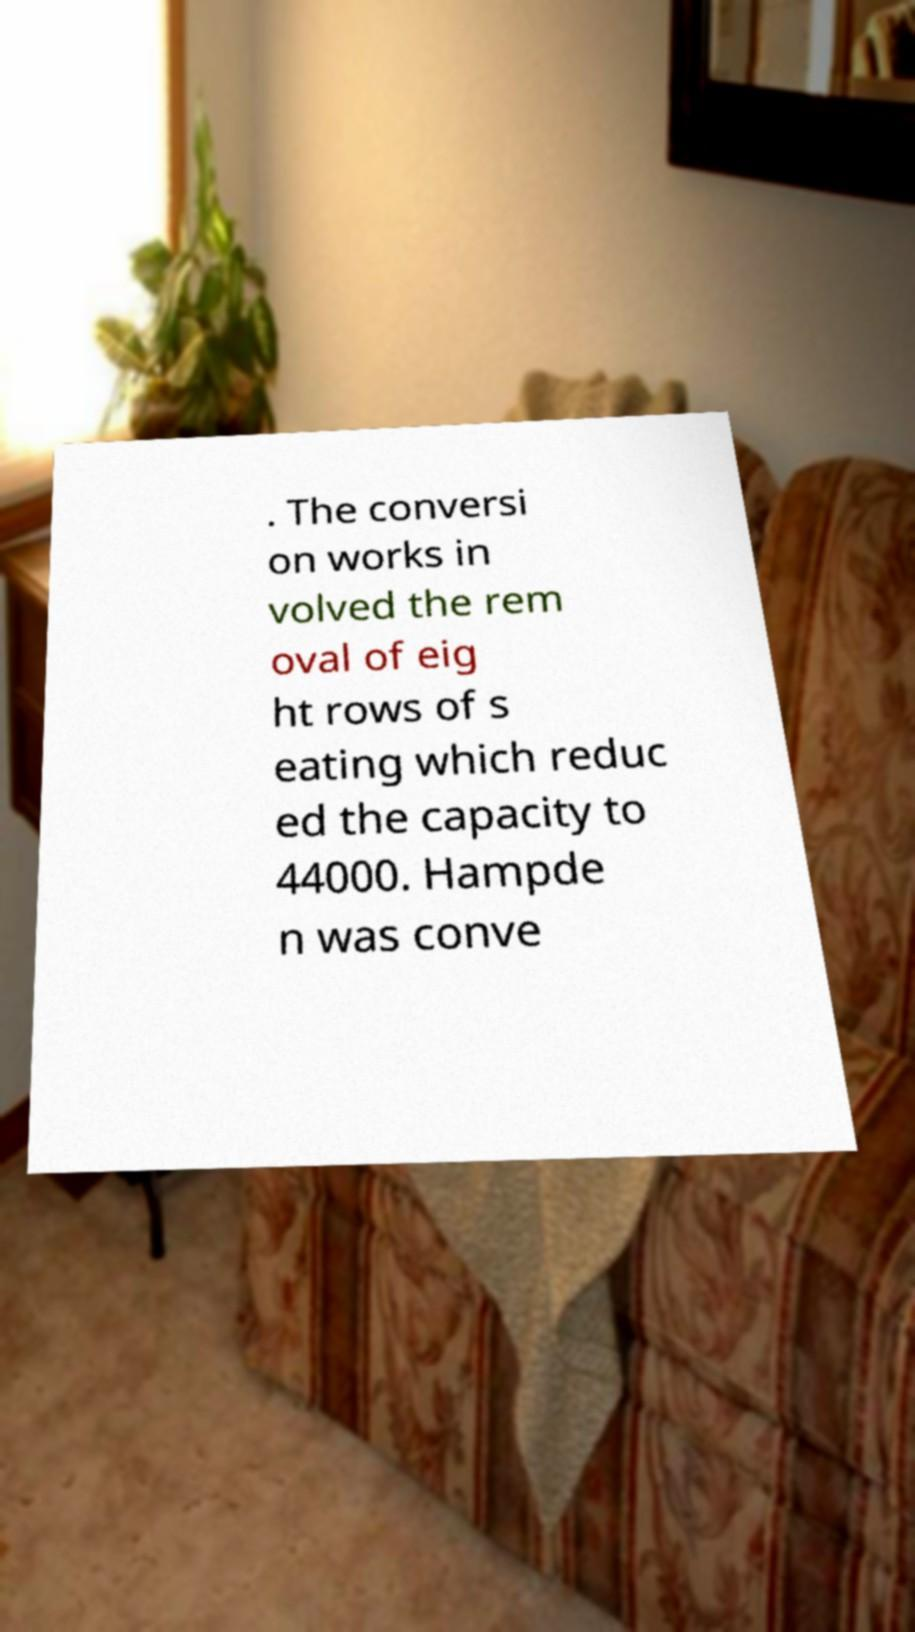For documentation purposes, I need the text within this image transcribed. Could you provide that? . The conversi on works in volved the rem oval of eig ht rows of s eating which reduc ed the capacity to 44000. Hampde n was conve 